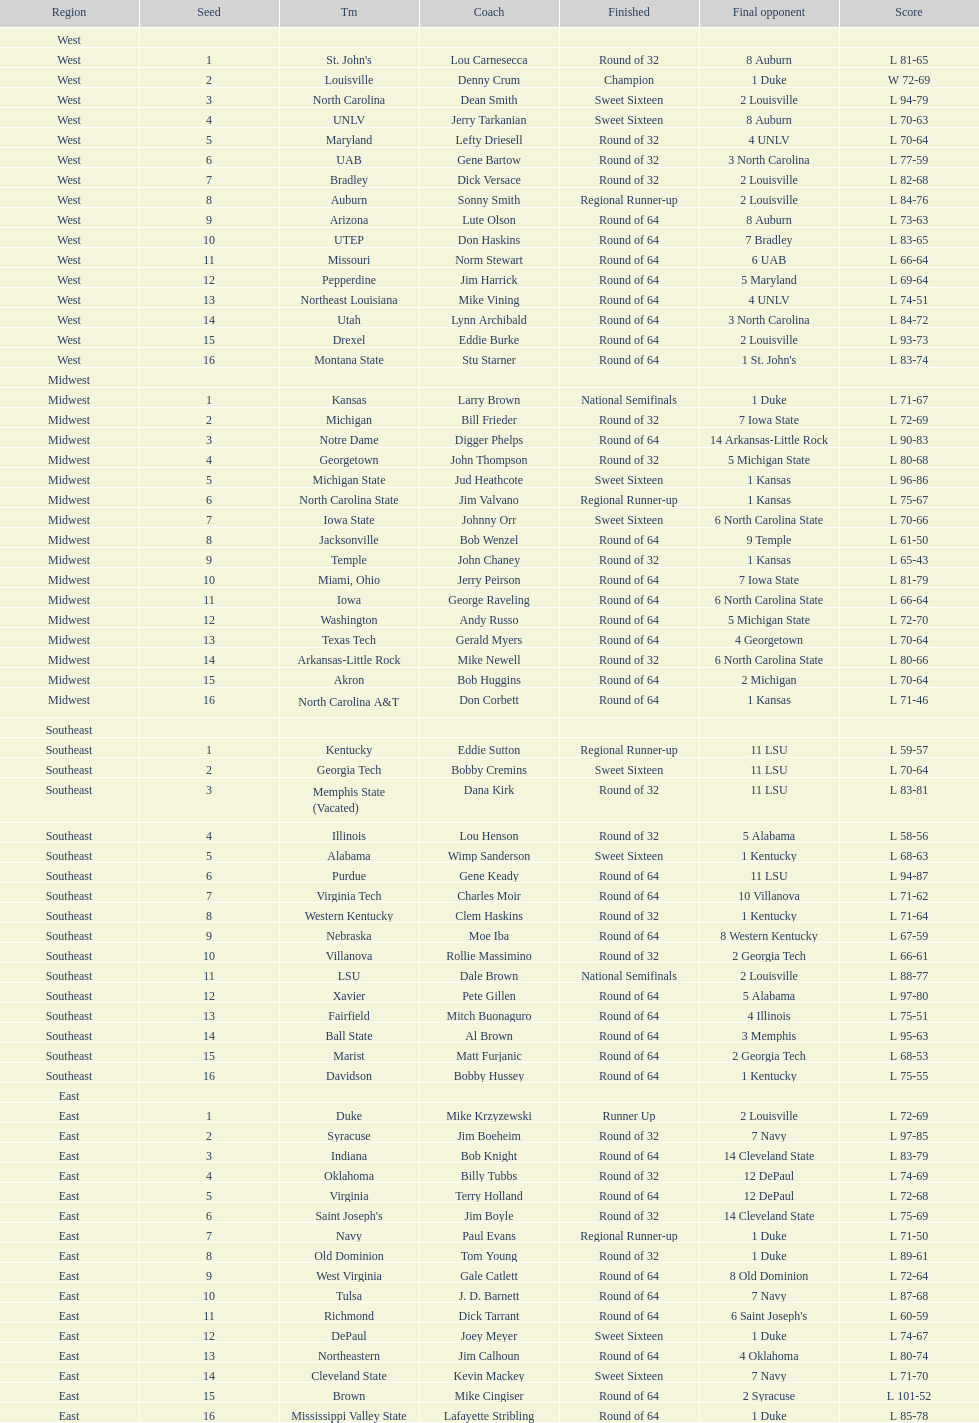How many number of teams played altogether? 64. 